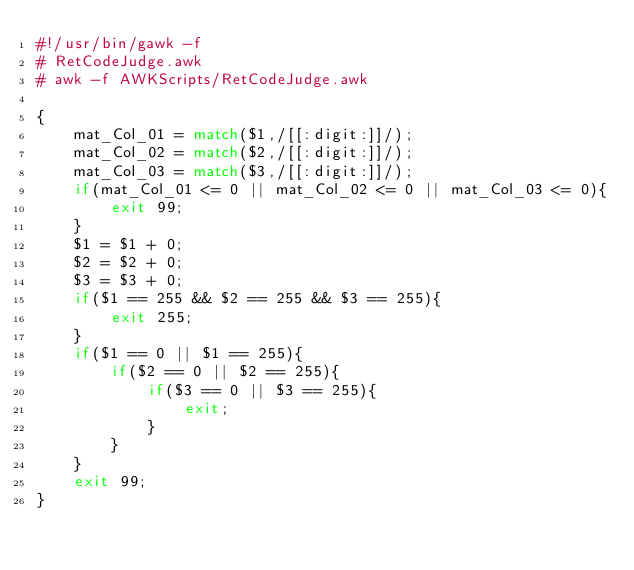<code> <loc_0><loc_0><loc_500><loc_500><_Awk_>#!/usr/bin/gawk -f
# RetCodeJudge.awk
# awk -f AWKScripts/RetCodeJudge.awk

{
	mat_Col_01 = match($1,/[[:digit:]]/);
	mat_Col_02 = match($2,/[[:digit:]]/);
	mat_Col_03 = match($3,/[[:digit:]]/);
	if(mat_Col_01 <= 0 || mat_Col_02 <= 0 || mat_Col_03 <= 0){
		exit 99;
	}
	$1 = $1 + 0;
	$2 = $2 + 0;
	$3 = $3 + 0;
	if($1 == 255 && $2 == 255 && $3 == 255){
		exit 255;
	}
	if($1 == 0 || $1 == 255){
		if($2 == 0 || $2 == 255){
			if($3 == 0 || $3 == 255){
				exit;
			}
		}
	}
	exit 99;
}

</code> 